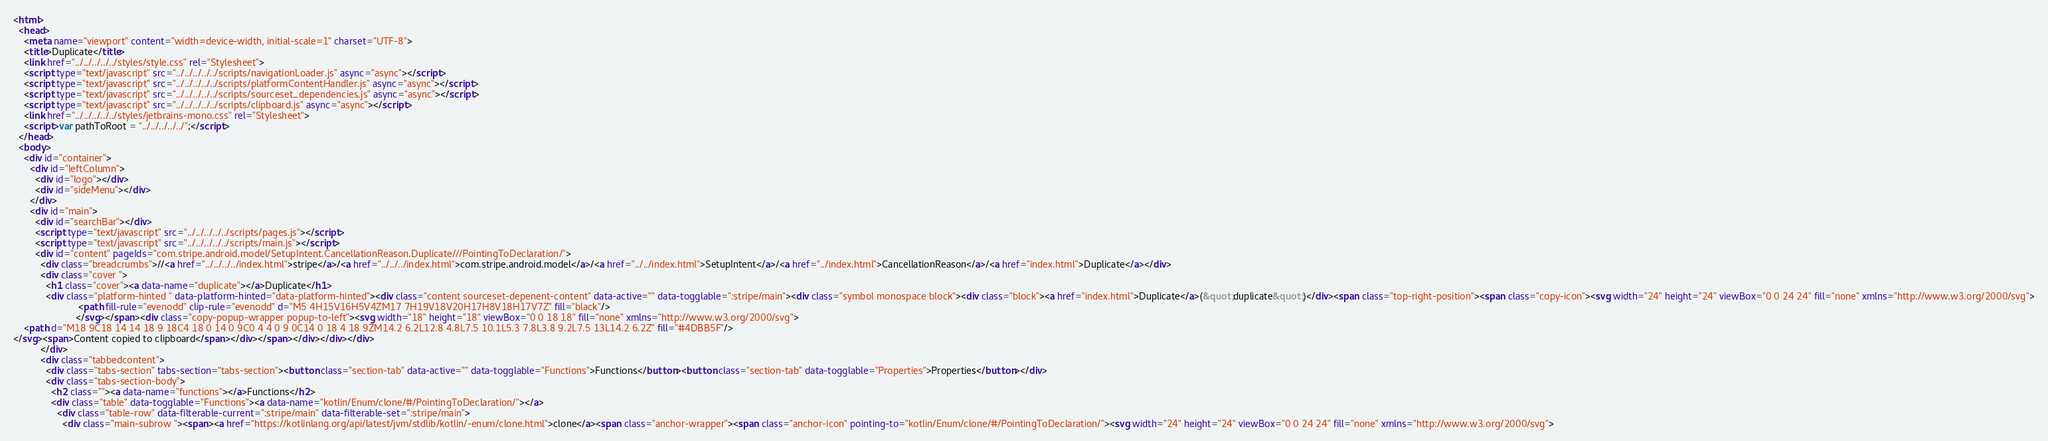Convert code to text. <code><loc_0><loc_0><loc_500><loc_500><_HTML_><html>
  <head>
    <meta name="viewport" content="width=device-width, initial-scale=1" charset="UTF-8">
    <title>Duplicate</title>
    <link href="../../../../../styles/style.css" rel="Stylesheet">
    <script type="text/javascript" src="../../../../../scripts/navigationLoader.js" async="async"></script>
    <script type="text/javascript" src="../../../../../scripts/platformContentHandler.js" async="async"></script>
    <script type="text/javascript" src="../../../../../scripts/sourceset_dependencies.js" async="async"></script>
    <script type="text/javascript" src="../../../../../scripts/clipboard.js" async="async"></script>
    <link href="../../../../../styles/jetbrains-mono.css" rel="Stylesheet">
    <script>var pathToRoot = "../../../../../";</script>
  </head>
  <body>
    <div id="container">
      <div id="leftColumn">
        <div id="logo"></div>
        <div id="sideMenu"></div>
      </div>
      <div id="main">
        <div id="searchBar"></div>
        <script type="text/javascript" src="../../../../../scripts/pages.js"></script>
        <script type="text/javascript" src="../../../../../scripts/main.js"></script>
        <div id="content" pageIds="com.stripe.android.model/SetupIntent.CancellationReason.Duplicate///PointingToDeclaration/">
          <div class="breadcrumbs">//<a href="../../../../index.html">stripe</a>/<a href="../../../index.html">com.stripe.android.model</a>/<a href="../../index.html">SetupIntent</a>/<a href="../index.html">CancellationReason</a>/<a href="index.html">Duplicate</a></div>
          <div class="cover ">
            <h1 class="cover"><a data-name="duplicate"></a>Duplicate</h1>
            <div class="platform-hinted " data-platform-hinted="data-platform-hinted"><div class="content sourceset-depenent-content" data-active="" data-togglable=":stripe/main"><div class="symbol monospace block"><div class="block"><a href="index.html">Duplicate</a>(&quot;duplicate&quot;)</div><span class="top-right-position"><span class="copy-icon"><svg width="24" height="24" viewBox="0 0 24 24" fill="none" xmlns="http://www.w3.org/2000/svg">
                        <path fill-rule="evenodd" clip-rule="evenodd" d="M5 4H15V16H5V4ZM17 7H19V18V20H17H8V18H17V7Z" fill="black"/>
                       </svg></span><div class="copy-popup-wrapper popup-to-left"><svg width="18" height="18" viewBox="0 0 18 18" fill="none" xmlns="http://www.w3.org/2000/svg">
    <path d="M18 9C18 14 14 18 9 18C4 18 0 14 0 9C0 4 4 0 9 0C14 0 18 4 18 9ZM14.2 6.2L12.8 4.8L7.5 10.1L5.3 7.8L3.8 9.2L7.5 13L14.2 6.2Z" fill="#4DBB5F"/>
</svg><span>Content copied to clipboard</span></div></span></div></div></div>
          </div>
          <div class="tabbedcontent">
            <div class="tabs-section" tabs-section="tabs-section"><button class="section-tab" data-active="" data-togglable="Functions">Functions</button><button class="section-tab" data-togglable="Properties">Properties</button></div>
            <div class="tabs-section-body">
              <h2 class=""><a data-name="functions"></a>Functions</h2>
              <div class="table" data-togglable="Functions"><a data-name="kotlin/Enum/clone/#/PointingToDeclaration/"></a>
                <div class="table-row" data-filterable-current=":stripe/main" data-filterable-set=":stripe/main">
                  <div class="main-subrow "><span><a href="https://kotlinlang.org/api/latest/jvm/stdlib/kotlin/-enum/clone.html">clone</a><span class="anchor-wrapper"><span class="anchor-icon" pointing-to="kotlin/Enum/clone/#/PointingToDeclaration/"><svg width="24" height="24" viewBox="0 0 24 24" fill="none" xmlns="http://www.w3.org/2000/svg"></code> 